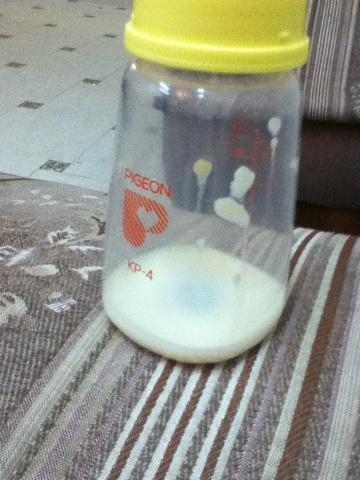Can you tell me more about this bottle's brand? Certainly! The bottle is from the brand 'Pigeon,' which is well-known for manufacturing high-quality baby products, including bottles, nipples, and baby accessories. Pigeon products are designed to cater to the needs of infants and young children. 